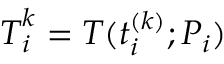Convert formula to latex. <formula><loc_0><loc_0><loc_500><loc_500>T _ { i } ^ { k } = T ( t _ { i } ^ { ( k ) } ; P _ { i } )</formula> 